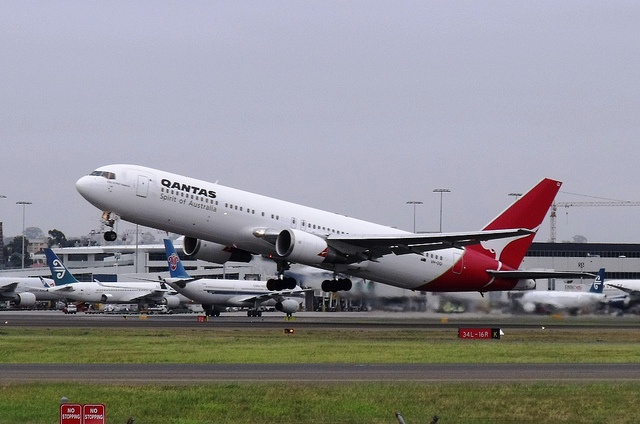Describe the objects in this image and their specific colors. I can see airplane in lavender, black, darkgray, and gray tones, airplane in lavender, black, darkgray, and gray tones, airplane in lavender, darkgray, gray, and black tones, airplane in lavender, darkgray, and gray tones, and airplane in lavender, black, darkgray, and gray tones in this image. 